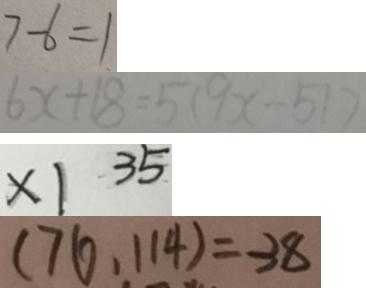<formula> <loc_0><loc_0><loc_500><loc_500>7 - 6 = 1 
 6 x + 1 8 = 5 ( 9 x - 5 1 ) 
 x 1 3 5 
 ( 7 6 , 1 1 4 ) = 3 8</formula> 